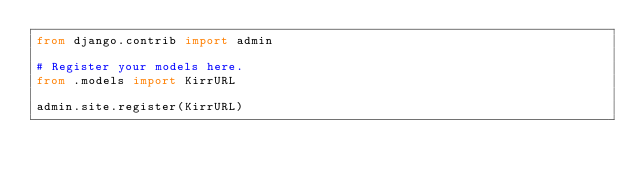Convert code to text. <code><loc_0><loc_0><loc_500><loc_500><_Python_>from django.contrib import admin

# Register your models here.
from .models import KirrURL

admin.site.register(KirrURL)

</code> 